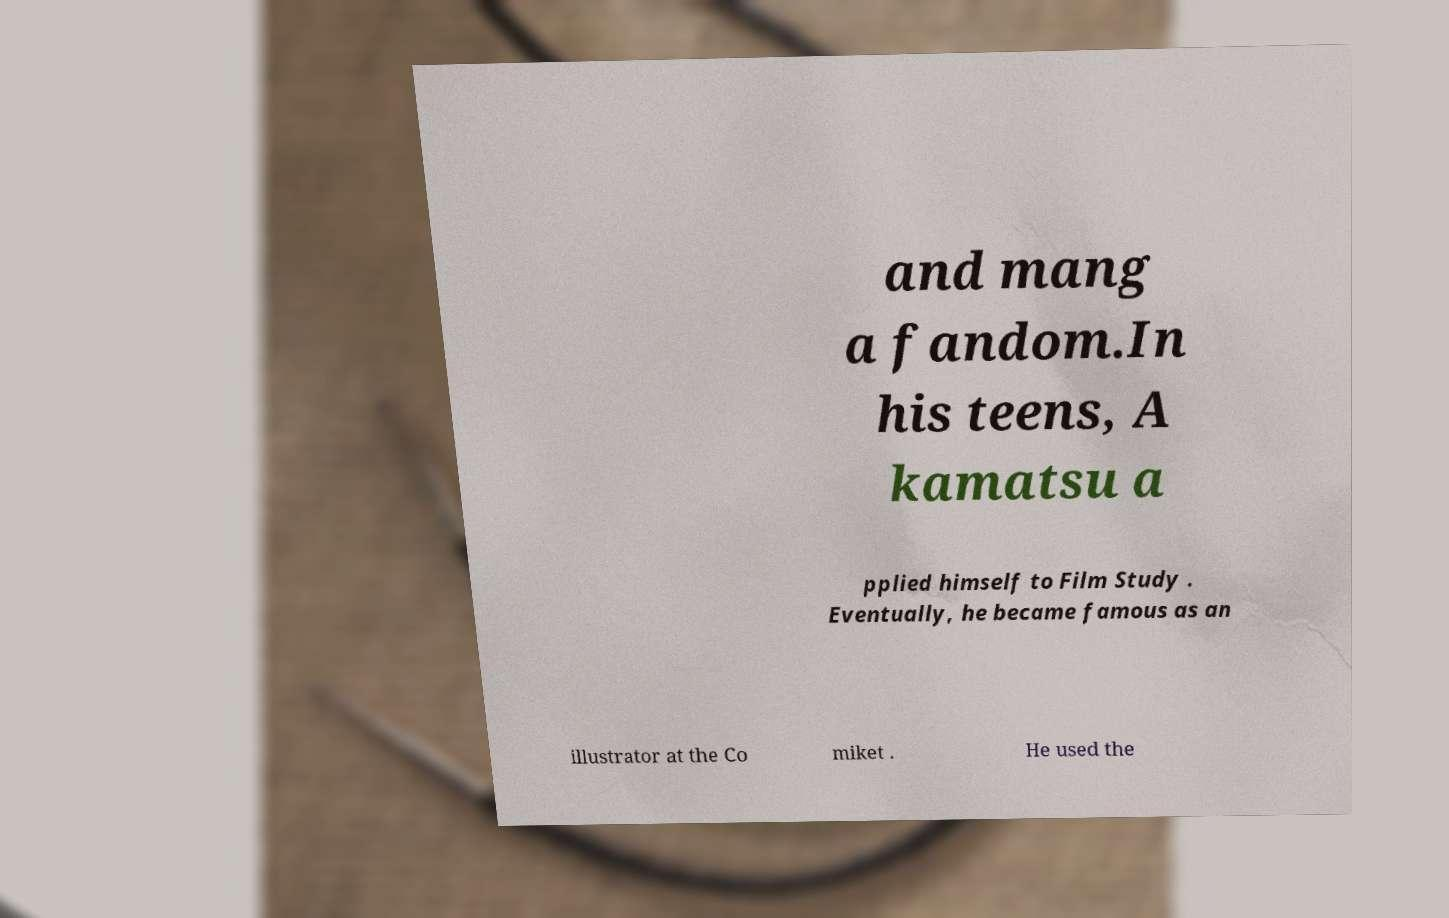What messages or text are displayed in this image? I need them in a readable, typed format. and mang a fandom.In his teens, A kamatsu a pplied himself to Film Study . Eventually, he became famous as an illustrator at the Co miket . He used the 